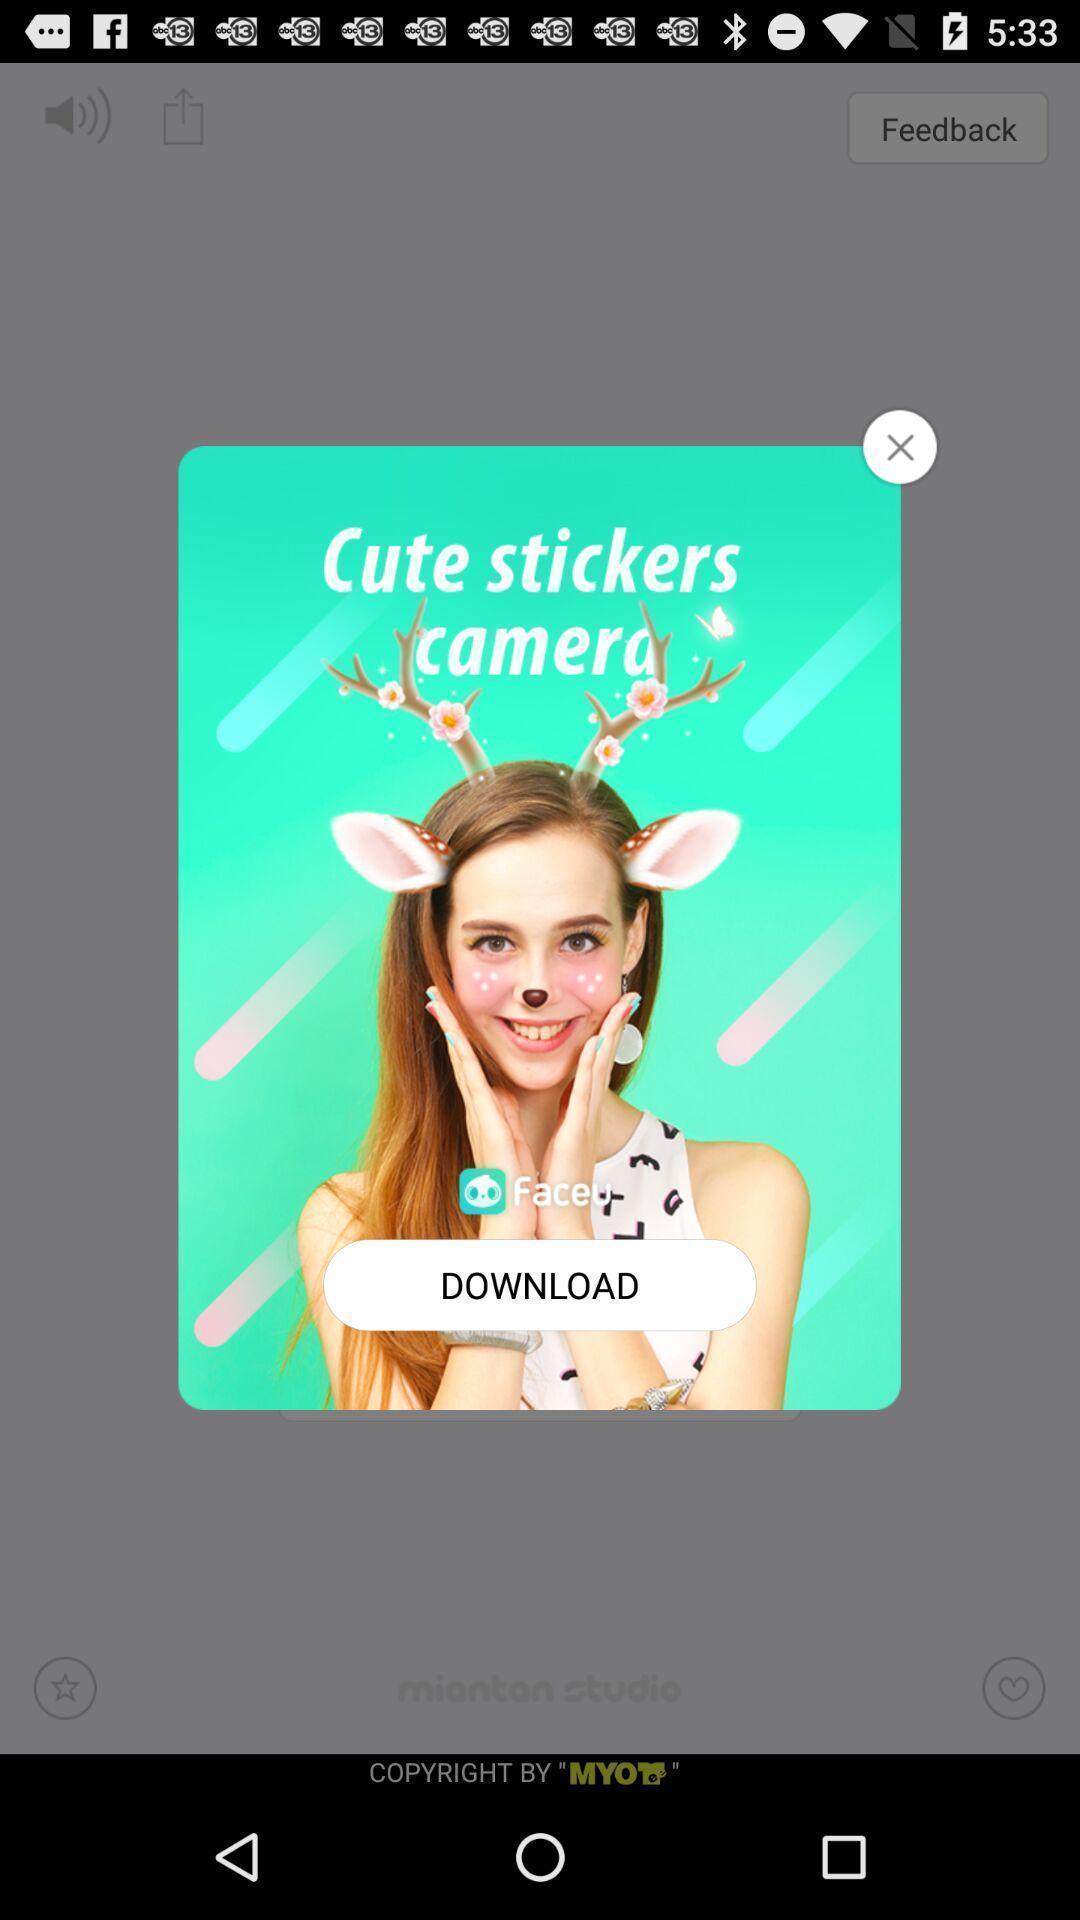What can you discern from this picture? Pop-up to download cute stickers for camera. 